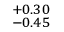Convert formula to latex. <formula><loc_0><loc_0><loc_500><loc_500>^ { + 0 . 3 0 } _ { - 0 . 4 5 }</formula> 